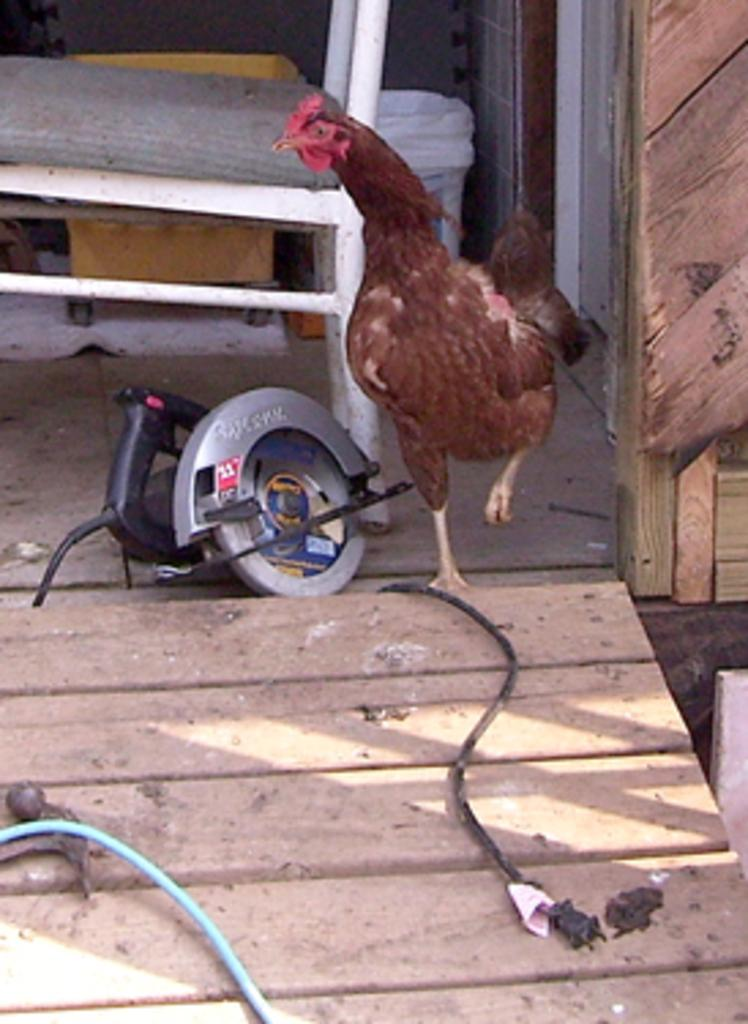What type of animal is in the image? There is a brown hen in the image. What object is present that is typically used for cutting or shaping materials? There is a wooden cutting machine in the image. What type of furniture can be seen in the image? There is a white chair in the image. What other wooden object is visible in the image? There is a wooden board in the image. Can you describe the girl playing with the horse in the image? There is no girl or horse present in the image; it features a brown hen, a wooden cutting machine, a white chair, and a wooden board. 